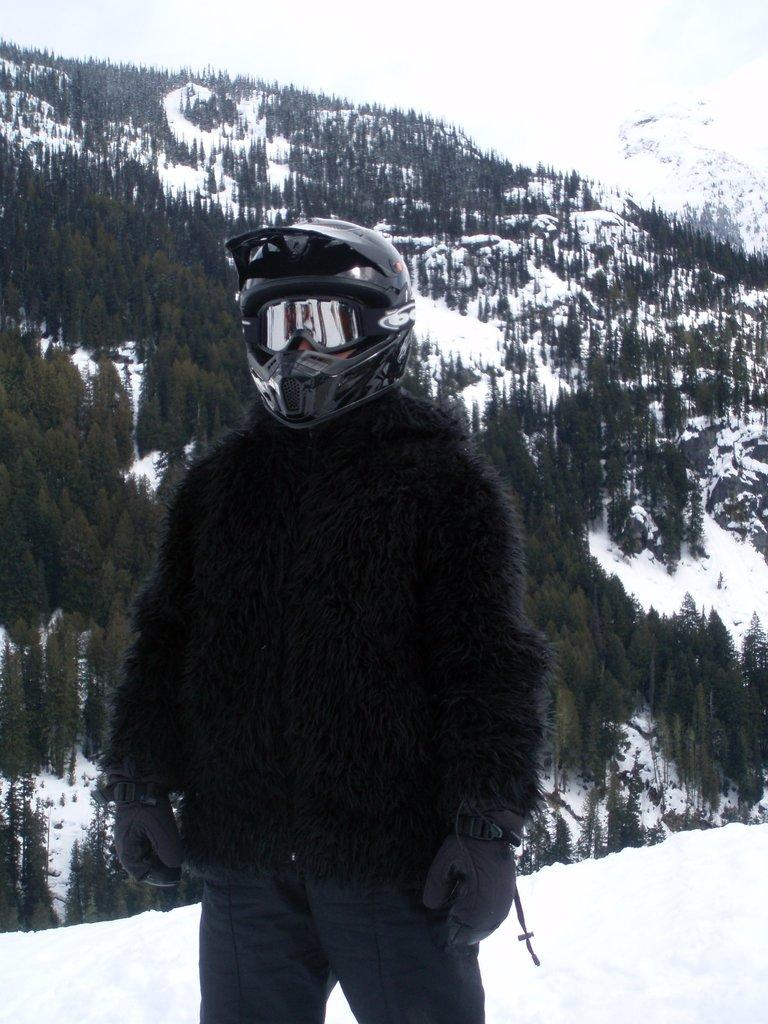What is the main subject of the image? There is a person standing in the center of the image. What protective gear is the person wearing? The person is wearing a helmet. What clothing items can be seen on the person? The person is wearing a jacket and gloves. What can be seen in the background of the image? There is a hill, trees, and snow in the background of the image. What type of root can be seen growing on the person's skin in the image? There is no root or skin visible in the image; the person is wearing a helmet, jacket, and gloves. 